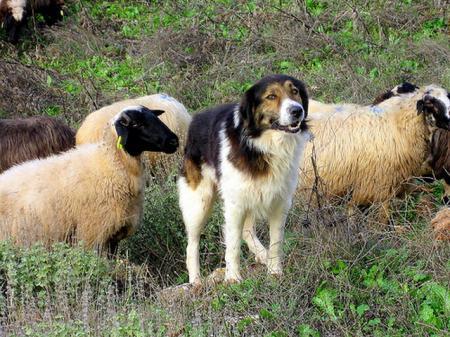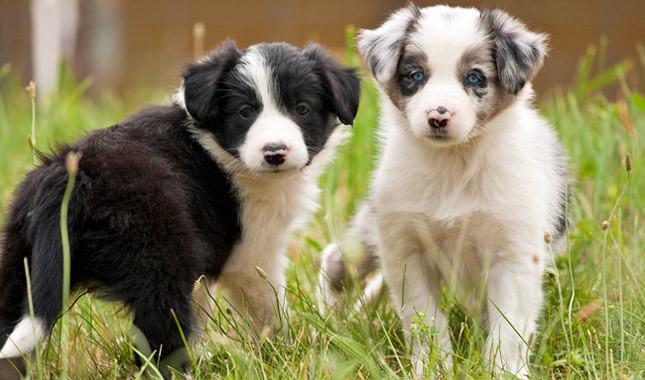The first image is the image on the left, the second image is the image on the right. Analyze the images presented: Is the assertion "There are two dogs" valid? Answer yes or no. No. The first image is the image on the left, the second image is the image on the right. Considering the images on both sides, is "In one image, a dog is shown with sheep." valid? Answer yes or no. Yes. 